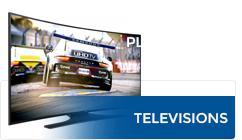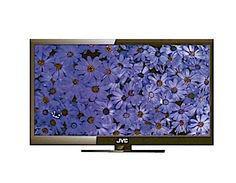The first image is the image on the left, the second image is the image on the right. For the images displayed, is the sentence "Atleast one tv has an image of something alive." factually correct? Answer yes or no. Yes. The first image is the image on the left, the second image is the image on the right. Analyze the images presented: Is the assertion "There is a QLED TV in the left image." valid? Answer yes or no. No. 